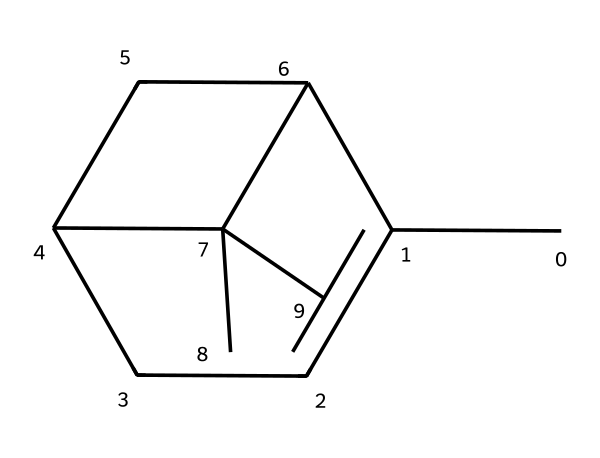What is the molecular formula for the chemical represented by the SMILES? To derive the molecular formula, count the number of each type of atom in the provided SMILES. The structure shows 10 carbon (C) atoms and 16 hydrogen (H) atoms, leading to the formula C10H16.
Answer: C10H16 How many rings are present in the structure of this chemical? By analyzing the SMILES, we can see that there are two ring structures formed by the arrangement of carbon atoms. Each ring is denoted by the use of numbers. Thus, the answer is two rings.
Answer: 2 Is this chemical an acyclic or cyclic compound? The presence of the numbered rings in the SMILES indicates that this molecule has a cyclic structure, meaning it is not acyclic. Therefore, it is classified as cyclic.
Answer: cyclic What type of compound is represented by this SMILES? The SMILES pertains to a terpene, a specific class of compounds known for their aromatic properties, which are typically derived from plant sources. This classification is based on its molecular structure that conforms to the characteristics of terpenes.
Answer: terpene What is the primary functional group indicated in the structure? By examining the structure, we observe that it contains only carbon and hydrogen, which suggests that there are no distinct functional groups like alcohols or acids present. Hence the primary functional group characteristic of this molecule is hydrocarbon.
Answer: hydrocarbon How does the structure contribute to its use in natural air fresheners? The structure of pinene, being a terpene, offers a pleasant aroma and is often associated with fresh, pine-like scents, making it ideal for use in air fresheners. This aromatic property is attributed to its cyclic and branched structure, which enhances its volatility and fragrance profile.
Answer: pleasant aroma 